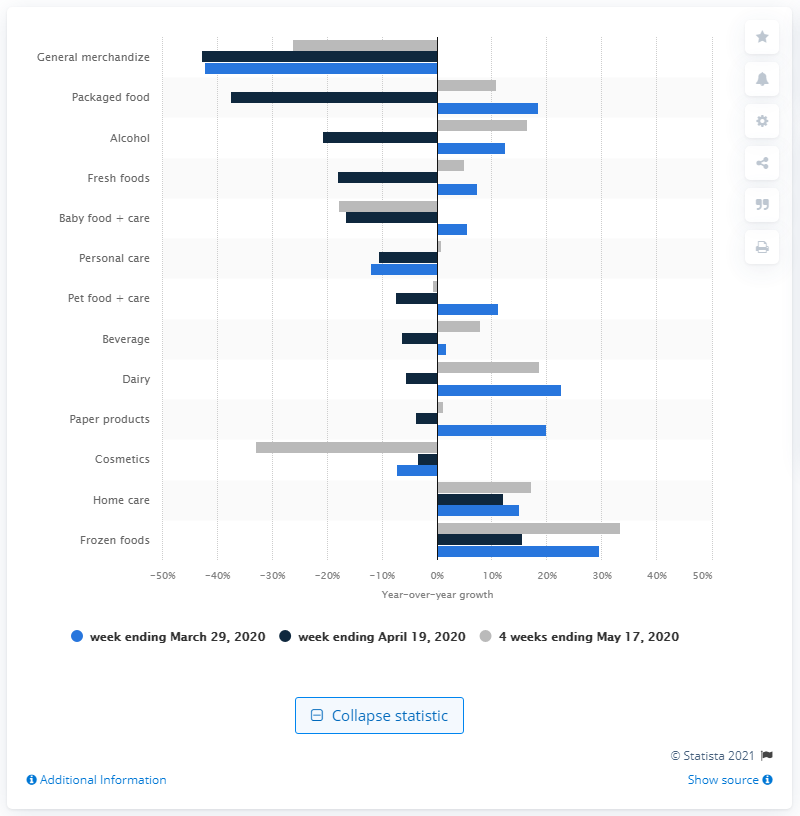Specify some key components in this picture. The growth of over-the-counter healthcare products reported in the four weeks ending in May 17 was 29.6%. The sales value of frozen foods in Italy as of March 29, 2020 was 29.6 billion euros. 